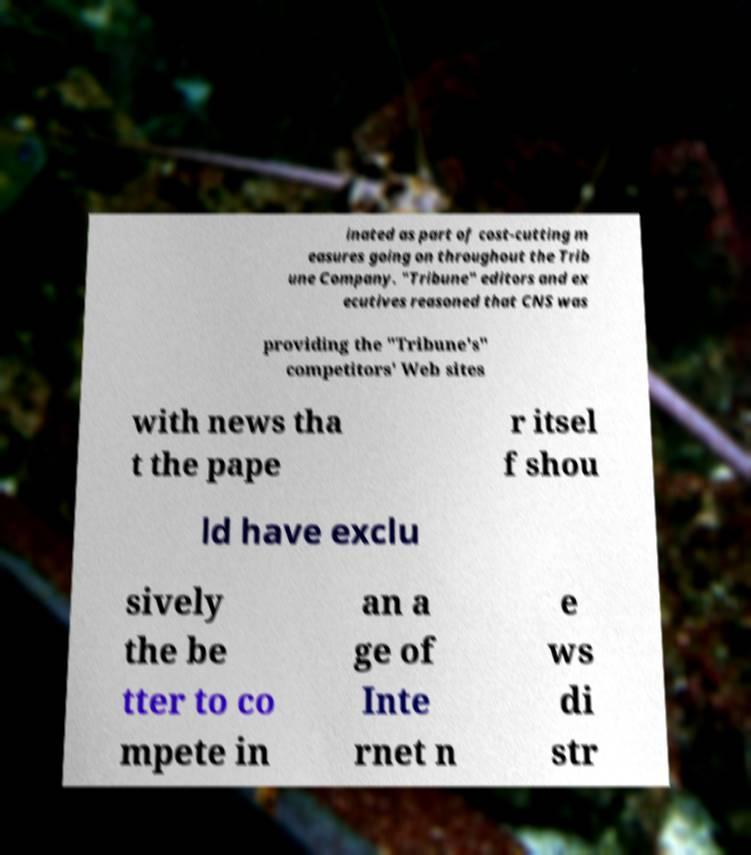For documentation purposes, I need the text within this image transcribed. Could you provide that? inated as part of cost-cutting m easures going on throughout the Trib une Company. "Tribune" editors and ex ecutives reasoned that CNS was providing the "Tribune's" competitors' Web sites with news tha t the pape r itsel f shou ld have exclu sively the be tter to co mpete in an a ge of Inte rnet n e ws di str 